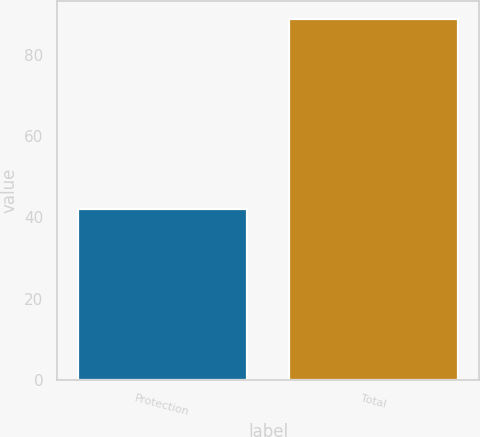Convert chart to OTSL. <chart><loc_0><loc_0><loc_500><loc_500><bar_chart><fcel>Protection<fcel>Total<nl><fcel>42<fcel>89<nl></chart> 